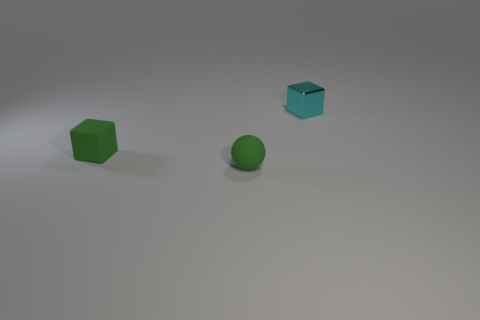What number of other things are the same size as the rubber sphere?
Offer a very short reply. 2. There is a matte object in front of the small green object that is on the left side of the green matte sphere; is there a tiny cyan object that is to the right of it?
Keep it short and to the point. Yes. The green matte cube is what size?
Make the answer very short. Small. There is a block that is right of the small rubber sphere; what is its size?
Provide a short and direct response. Small. There is a rubber sphere in front of the green matte block; is it the same size as the cyan object?
Offer a terse response. Yes. Is there any other thing that has the same color as the metallic thing?
Provide a short and direct response. No. What shape is the cyan object?
Give a very brief answer. Cube. What number of things are behind the green matte sphere and left of the metal cube?
Offer a very short reply. 1. Does the small rubber cube have the same color as the small matte ball?
Offer a very short reply. Yes. Is there any other thing that is the same material as the cyan thing?
Make the answer very short. No. 